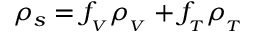<formula> <loc_0><loc_0><loc_500><loc_500>\rho _ { s } = f _ { _ { V } } \rho _ { _ { V } } + f _ { _ { T } } \rho _ { _ { T } }</formula> 